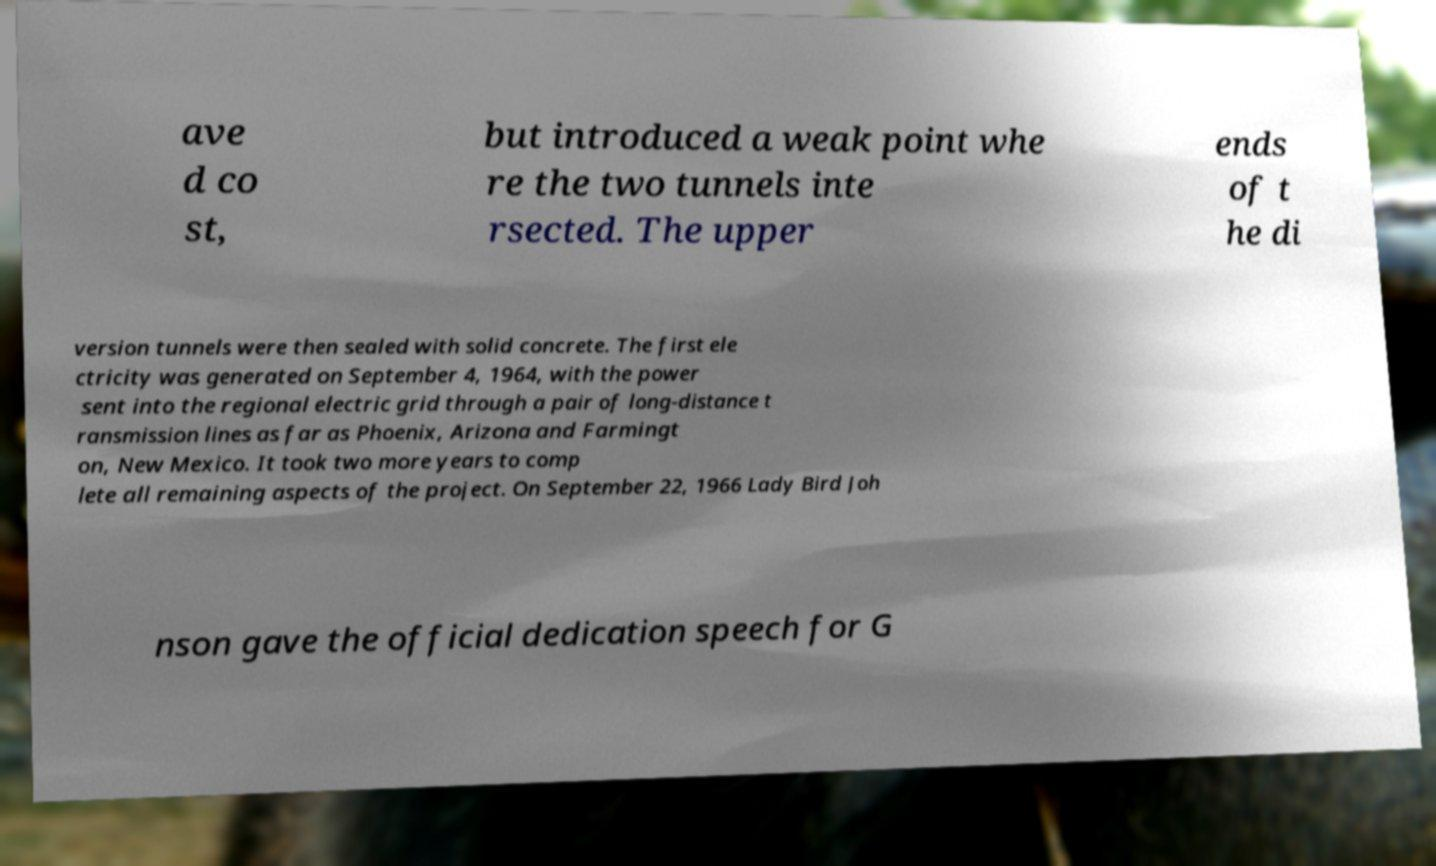For documentation purposes, I need the text within this image transcribed. Could you provide that? ave d co st, but introduced a weak point whe re the two tunnels inte rsected. The upper ends of t he di version tunnels were then sealed with solid concrete. The first ele ctricity was generated on September 4, 1964, with the power sent into the regional electric grid through a pair of long-distance t ransmission lines as far as Phoenix, Arizona and Farmingt on, New Mexico. It took two more years to comp lete all remaining aspects of the project. On September 22, 1966 Lady Bird Joh nson gave the official dedication speech for G 